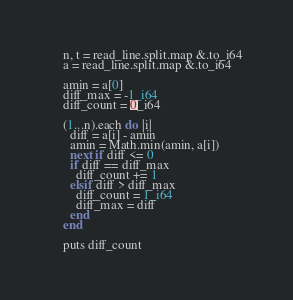<code> <loc_0><loc_0><loc_500><loc_500><_Crystal_>    n, t = read_line.split.map &.to_i64
    a = read_line.split.map &.to_i64

    amin = a[0]
    diff_max = -1_i64
    diff_count = 0_i64

    (1...n).each do |i|
      diff = a[i] - amin
      amin = Math.min(amin, a[i])
      next if diff <= 0
      if diff == diff_max
        diff_count += 1
      elsif diff > diff_max
        diff_count = 1_i64
        diff_max = diff
      end
    end

    puts diff_count</code> 